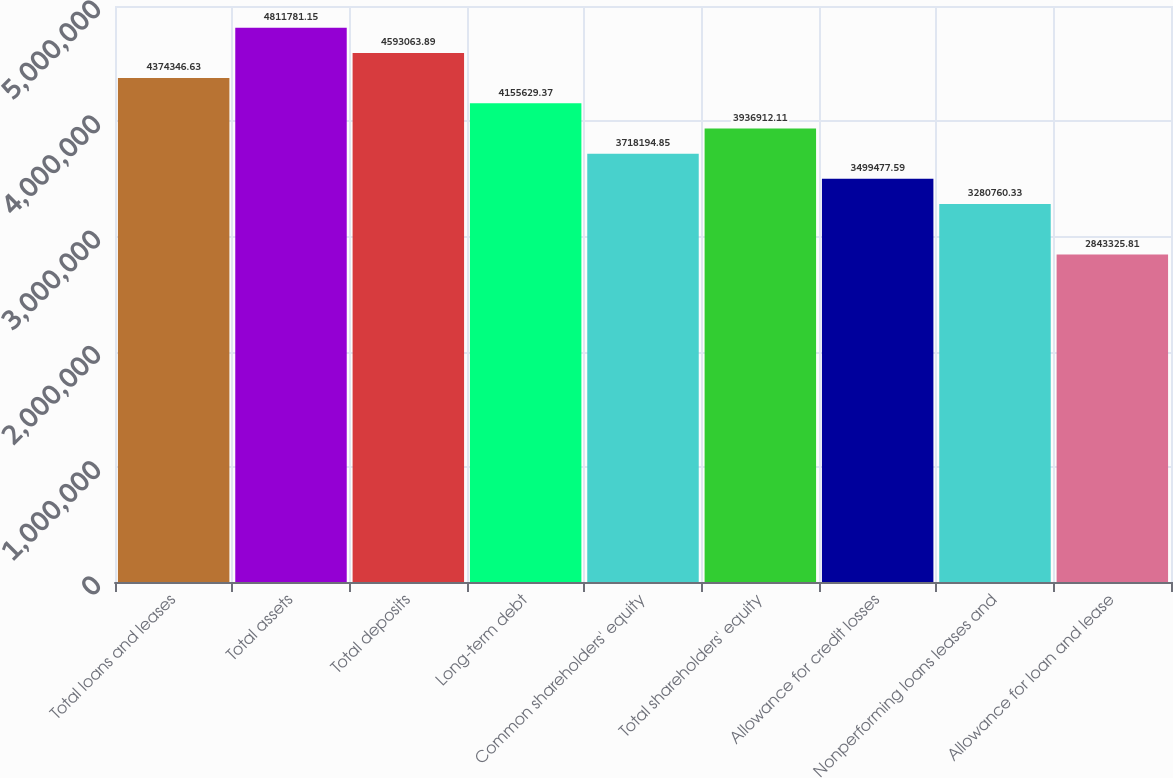Convert chart to OTSL. <chart><loc_0><loc_0><loc_500><loc_500><bar_chart><fcel>Total loans and leases<fcel>Total assets<fcel>Total deposits<fcel>Long-term debt<fcel>Common shareholders' equity<fcel>Total shareholders' equity<fcel>Allowance for credit losses<fcel>Nonperforming loans leases and<fcel>Allowance for loan and lease<nl><fcel>4.37435e+06<fcel>4.81178e+06<fcel>4.59306e+06<fcel>4.15563e+06<fcel>3.71819e+06<fcel>3.93691e+06<fcel>3.49948e+06<fcel>3.28076e+06<fcel>2.84333e+06<nl></chart> 